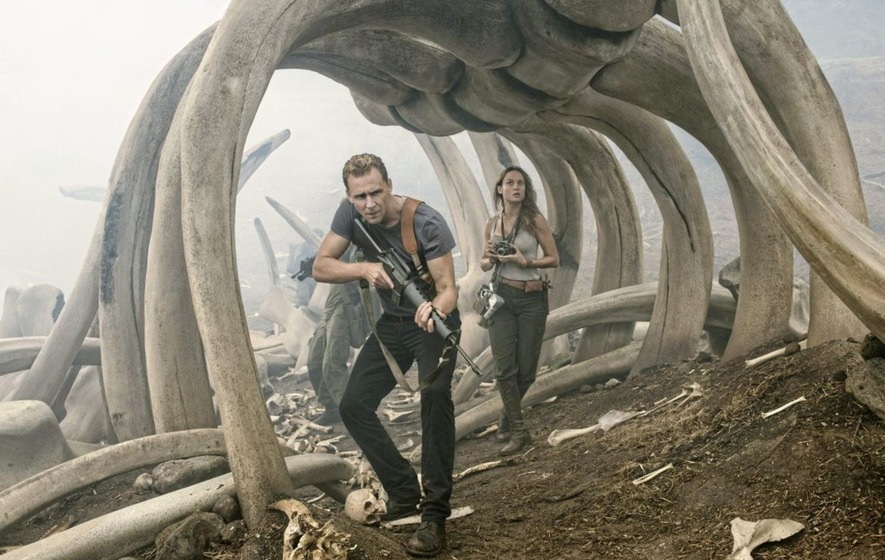What do you think is going on in this snapshot? In this captivating scene from the movie 'Kong: Skull Island,' we see the actors Tom Hiddleston and Brie Larson navigating through an eerie and desolate landscape. Hiddleston's character, Captain James Conrad, is gripping a machete with a determined look, while Larson's character, Mason Weaver, holds a camera, likely documenting their perilous journey. They are walking through an archway formed by massive, curved bones, suggesting they are in an ancient, mysterious place, possibly inhabited by gigantic creatures. The foggy atmosphere heightens the sense of danger and adventure, making the scene both thrilling and foreboding. 